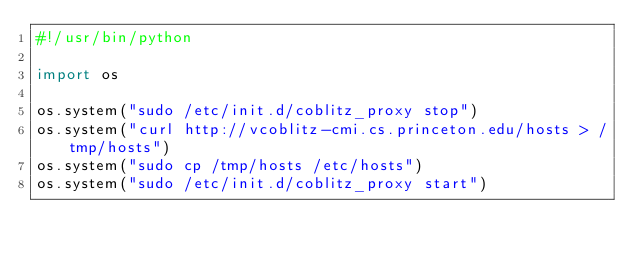<code> <loc_0><loc_0><loc_500><loc_500><_Python_>#!/usr/bin/python

import os

os.system("sudo /etc/init.d/coblitz_proxy stop")
os.system("curl http://vcoblitz-cmi.cs.princeton.edu/hosts > /tmp/hosts")
os.system("sudo cp /tmp/hosts /etc/hosts")
os.system("sudo /etc/init.d/coblitz_proxy start")
</code> 